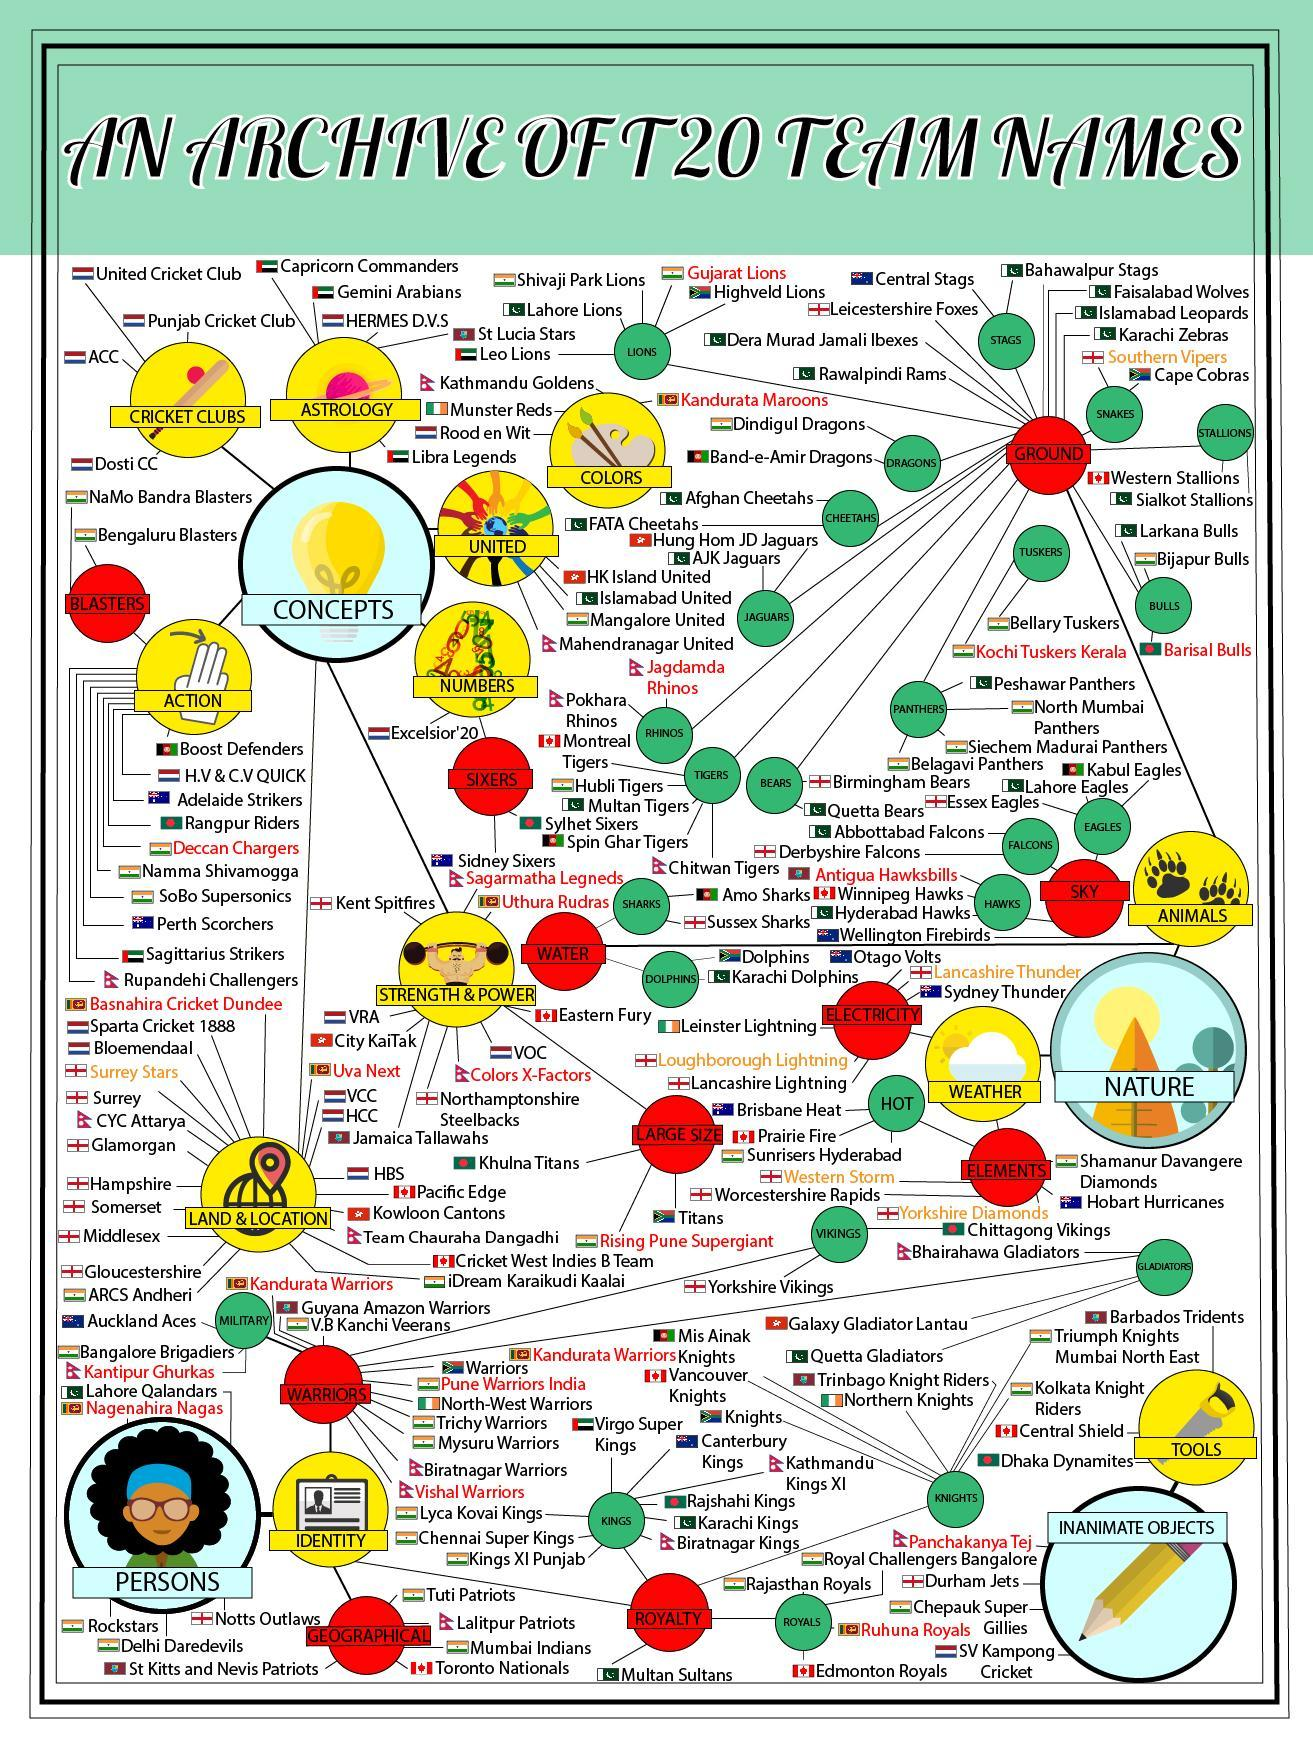Which are the team names ending with the word "Vikings"?
Answer the question with a short phrase. Yorkshire Vikings, Chittagong Vikings Which are the team names ending with the word "Royals"? Rajasthan Royals, Edmonton Royals How many team names are there having "Gladiator" in it? 3 How many teams have name ending with the names of aquatic animals? 4 which are the teams that have name ending with "Stags"? central stags, Bahawalpur stags Which are the team names that are related to snake? Cape cobras, southern vipers How many teams have name ending with "Dragons" or "Cheetahs"? 4 Which are the team names ending with the word "eagles"? Essex Eagles, Lahore Eagles, Kabul Eagles How many team names are related to colors? 4 which are the teams that have name ending with "Dragons"? Dindigul dragons, Band-e Amir dragons, How many teams have name ending with "Cricket club"? 4 Which are the team names ending with the word "Rhinos"? Pokhara Rhinos, Jagdamda Rhinos How many team names are there having "Kings" in it? 9 which are the teams that have name ending with "Bulls"? Larkana bulls, Bijapur bulls, Barisal bulls How many teams have name ending with "Lions"? 5 